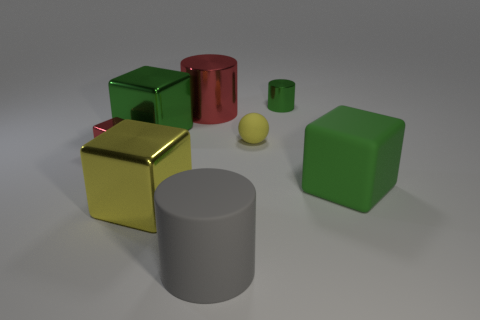Add 2 rubber balls. How many objects exist? 10 Subtract all gray cylinders. How many cylinders are left? 2 Subtract all metal cubes. How many cubes are left? 1 Add 8 red shiny cylinders. How many red shiny cylinders are left? 9 Add 3 big yellow things. How many big yellow things exist? 4 Subtract 1 green cylinders. How many objects are left? 7 Subtract all balls. How many objects are left? 7 Subtract 3 blocks. How many blocks are left? 1 Subtract all yellow cubes. Subtract all cyan spheres. How many cubes are left? 3 Subtract all gray balls. How many purple cylinders are left? 0 